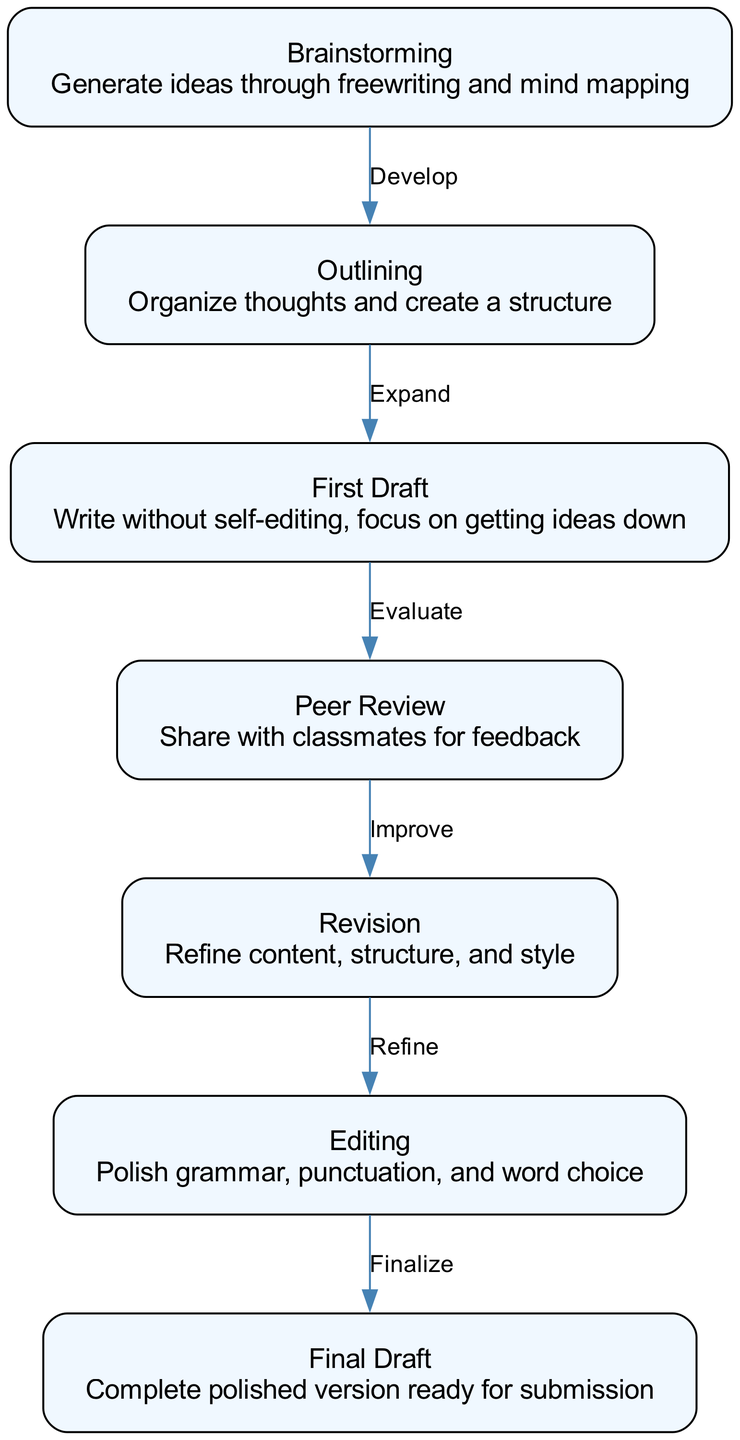What is the first step in the writing process? The first node in the diagram is "Brainstorming," which is where the writing process begins by generating ideas.
Answer: Brainstorming How many nodes are there in the diagram? The diagram lists a total of seven nodes which represent each stage of the writing process from brainstorming to final draft.
Answer: Seven What label connects "First Draft" and "Peer Review"? The edge connecting these two nodes is labeled "Evaluate," indicating that the process of evaluation occurs between writing the first draft and sharing it for peer review.
Answer: Evaluate Which step follows "Revision"? According to the flowchart, the step that follows "Revision" is "Editing," as shown by the directed edge that leads from revision to editing.
Answer: Editing What is the relationship between "Outlining" and "First Draft"? The label on the edge connecting "Outlining" to "First Draft" is "Expand," pointing to the idea that outlining helps to expand the initial ideas into a draft.
Answer: Expand After "Peer Review," what is the next phase in the writing process? The phase that follows "Peer Review" in the flowchart is "Revision," as indicated by the directed edge leading from peer review to revision.
Answer: Revision What does the process end with? The final node in the writing process represented in the diagram is "Final Draft," signifying the completion of the writing workflow.
Answer: Final Draft How many edges are in the diagram? There are six edges that connect the different nodes in the writing process flowchart, indicating the progression from one step to another.
Answer: Six Which node is directly after "Editing"? The node that comes directly after "Editing" is "Final Draft," as shown by the directed flow from editing to the final draft.
Answer: Final Draft 